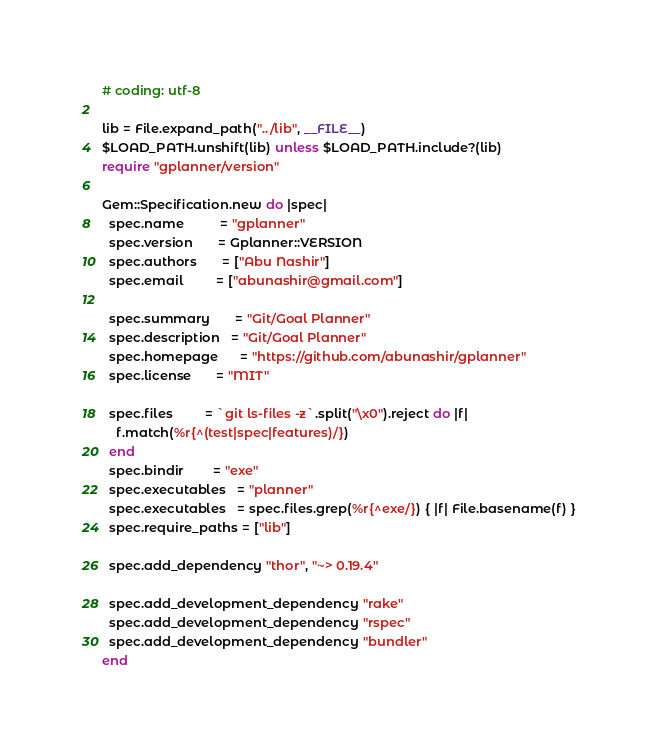<code> <loc_0><loc_0><loc_500><loc_500><_Ruby_># coding: utf-8

lib = File.expand_path("../lib", __FILE__)
$LOAD_PATH.unshift(lib) unless $LOAD_PATH.include?(lib)
require "gplanner/version"

Gem::Specification.new do |spec|
  spec.name          = "gplanner"
  spec.version       = Gplanner::VERSION
  spec.authors       = ["Abu Nashir"]
  spec.email         = ["abunashir@gmail.com"]

  spec.summary       = "Git/Goal Planner"
  spec.description   = "Git/Goal Planner"
  spec.homepage      = "https://github.com/abunashir/gplanner"
  spec.license       = "MIT"

  spec.files         = `git ls-files -z`.split("\x0").reject do |f|
    f.match(%r{^(test|spec|features)/})
  end
  spec.bindir        = "exe"
  spec.executables   = "planner"
  spec.executables   = spec.files.grep(%r{^exe/}) { |f| File.basename(f) }
  spec.require_paths = ["lib"]

  spec.add_dependency "thor", "~> 0.19.4"

  spec.add_development_dependency "rake"
  spec.add_development_dependency "rspec"
  spec.add_development_dependency "bundler"
end
</code> 